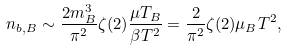Convert formula to latex. <formula><loc_0><loc_0><loc_500><loc_500>n _ { b , B } \sim \frac { 2 m _ { B } ^ { 3 } } { \pi ^ { 2 } } \zeta ( 2 ) \frac { \mu T _ { B } } { \beta T ^ { 2 } } = \frac { 2 } { \pi ^ { 2 } } \zeta ( 2 ) \mu _ { B } T ^ { 2 } ,</formula> 